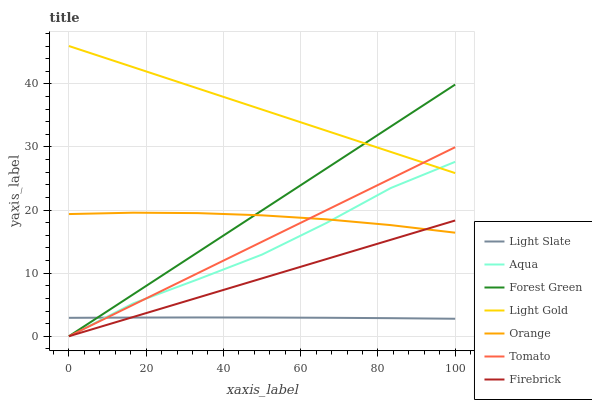Does Firebrick have the minimum area under the curve?
Answer yes or no. No. Does Firebrick have the maximum area under the curve?
Answer yes or no. No. Is Light Slate the smoothest?
Answer yes or no. No. Is Light Slate the roughest?
Answer yes or no. No. Does Light Slate have the lowest value?
Answer yes or no. No. Does Firebrick have the highest value?
Answer yes or no. No. Is Light Slate less than Orange?
Answer yes or no. Yes. Is Light Gold greater than Orange?
Answer yes or no. Yes. Does Light Slate intersect Orange?
Answer yes or no. No. 